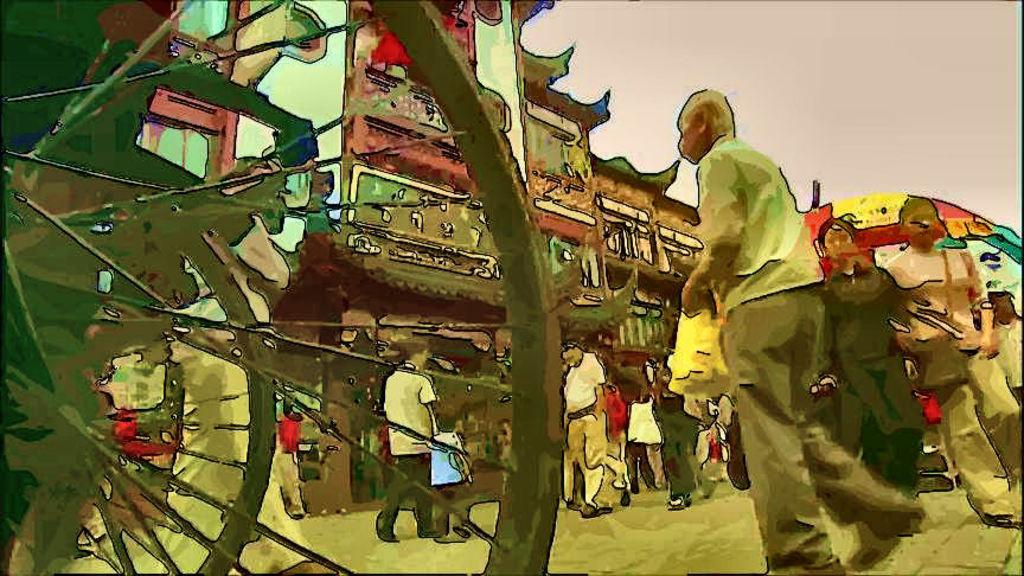What types of living organisms can be seen in the image? People can be seen in the image. What type of structures are present in the image? Buildings are present in the image. What type of train can be seen in the image? There is no train present in the image. What is the reason for the people saying good-bye in the image? There is no indication in the image that the people are saying good-bye, as their actions or expressions are not visible. What type of spark can be seen in the image? There is no spark present in the image. 